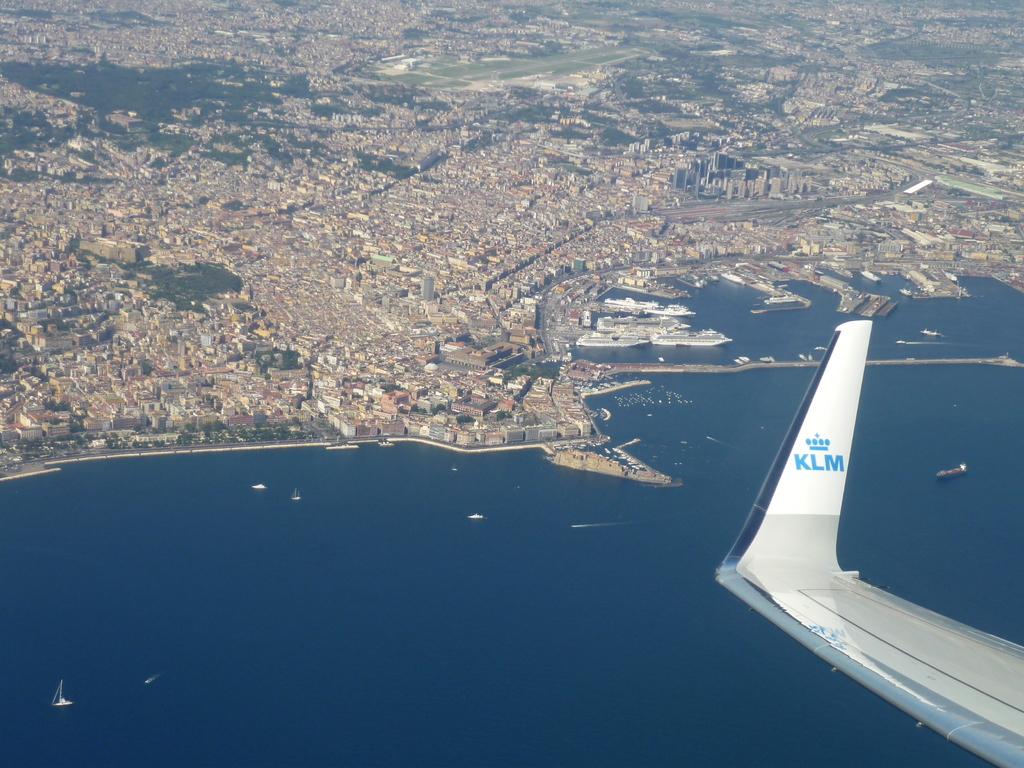What letters are on the plane wing?
Ensure brevity in your answer.  Klm. 